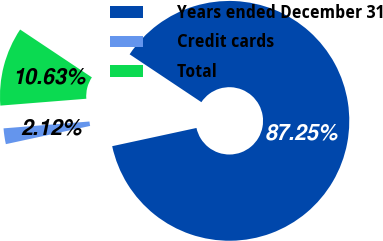<chart> <loc_0><loc_0><loc_500><loc_500><pie_chart><fcel>Years ended December 31<fcel>Credit cards<fcel>Total<nl><fcel>87.24%<fcel>2.12%<fcel>10.63%<nl></chart> 